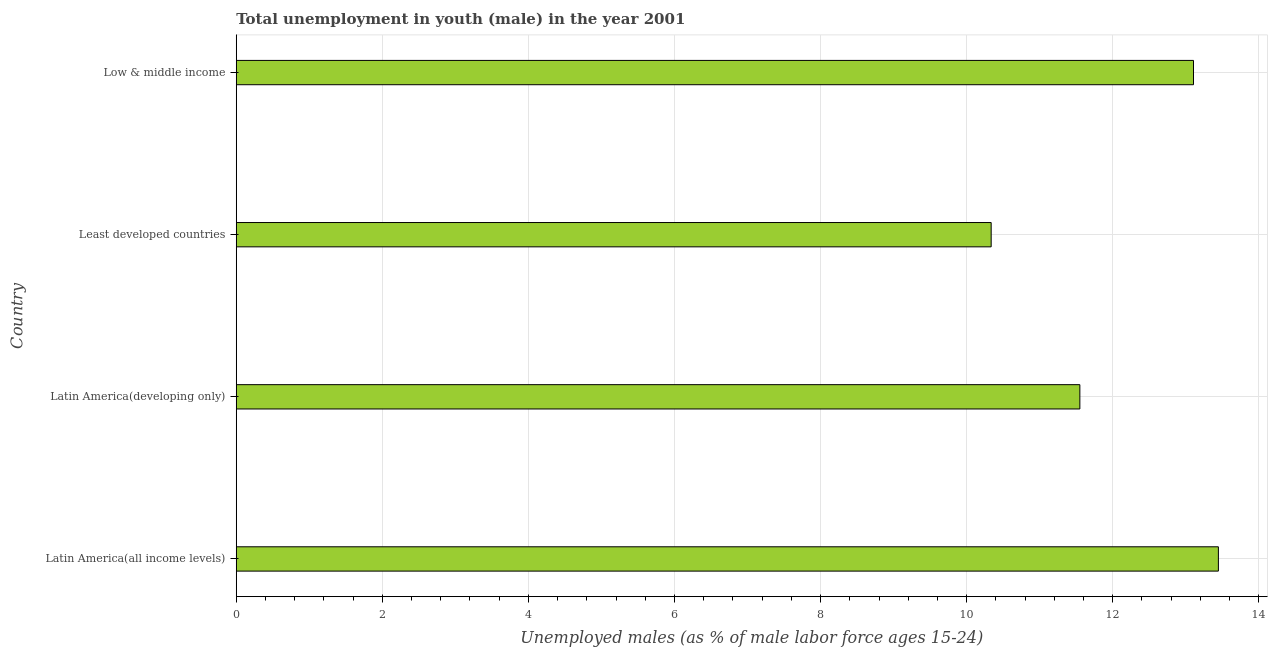Does the graph contain grids?
Your response must be concise. Yes. What is the title of the graph?
Your answer should be very brief. Total unemployment in youth (male) in the year 2001. What is the label or title of the X-axis?
Provide a succinct answer. Unemployed males (as % of male labor force ages 15-24). What is the unemployed male youth population in Low & middle income?
Make the answer very short. 13.11. Across all countries, what is the maximum unemployed male youth population?
Keep it short and to the point. 13.45. Across all countries, what is the minimum unemployed male youth population?
Keep it short and to the point. 10.34. In which country was the unemployed male youth population maximum?
Your answer should be very brief. Latin America(all income levels). In which country was the unemployed male youth population minimum?
Provide a short and direct response. Least developed countries. What is the sum of the unemployed male youth population?
Give a very brief answer. 48.44. What is the difference between the unemployed male youth population in Least developed countries and Low & middle income?
Make the answer very short. -2.77. What is the average unemployed male youth population per country?
Provide a short and direct response. 12.11. What is the median unemployed male youth population?
Provide a succinct answer. 12.33. In how many countries, is the unemployed male youth population greater than 12.8 %?
Your answer should be very brief. 2. What is the ratio of the unemployed male youth population in Latin America(all income levels) to that in Latin America(developing only)?
Provide a succinct answer. 1.16. What is the difference between the highest and the second highest unemployed male youth population?
Offer a terse response. 0.34. Is the sum of the unemployed male youth population in Latin America(all income levels) and Low & middle income greater than the maximum unemployed male youth population across all countries?
Ensure brevity in your answer.  Yes. What is the difference between the highest and the lowest unemployed male youth population?
Your answer should be very brief. 3.11. In how many countries, is the unemployed male youth population greater than the average unemployed male youth population taken over all countries?
Provide a short and direct response. 2. How many countries are there in the graph?
Ensure brevity in your answer.  4. What is the difference between two consecutive major ticks on the X-axis?
Offer a terse response. 2. What is the Unemployed males (as % of male labor force ages 15-24) of Latin America(all income levels)?
Keep it short and to the point. 13.45. What is the Unemployed males (as % of male labor force ages 15-24) in Latin America(developing only)?
Make the answer very short. 11.55. What is the Unemployed males (as % of male labor force ages 15-24) in Least developed countries?
Offer a terse response. 10.34. What is the Unemployed males (as % of male labor force ages 15-24) in Low & middle income?
Provide a succinct answer. 13.11. What is the difference between the Unemployed males (as % of male labor force ages 15-24) in Latin America(all income levels) and Latin America(developing only)?
Ensure brevity in your answer.  1.9. What is the difference between the Unemployed males (as % of male labor force ages 15-24) in Latin America(all income levels) and Least developed countries?
Give a very brief answer. 3.11. What is the difference between the Unemployed males (as % of male labor force ages 15-24) in Latin America(all income levels) and Low & middle income?
Make the answer very short. 0.34. What is the difference between the Unemployed males (as % of male labor force ages 15-24) in Latin America(developing only) and Least developed countries?
Give a very brief answer. 1.21. What is the difference between the Unemployed males (as % of male labor force ages 15-24) in Latin America(developing only) and Low & middle income?
Make the answer very short. -1.56. What is the difference between the Unemployed males (as % of male labor force ages 15-24) in Least developed countries and Low & middle income?
Your answer should be compact. -2.77. What is the ratio of the Unemployed males (as % of male labor force ages 15-24) in Latin America(all income levels) to that in Latin America(developing only)?
Keep it short and to the point. 1.16. What is the ratio of the Unemployed males (as % of male labor force ages 15-24) in Latin America(all income levels) to that in Least developed countries?
Your answer should be compact. 1.3. What is the ratio of the Unemployed males (as % of male labor force ages 15-24) in Latin America(all income levels) to that in Low & middle income?
Offer a terse response. 1.03. What is the ratio of the Unemployed males (as % of male labor force ages 15-24) in Latin America(developing only) to that in Least developed countries?
Keep it short and to the point. 1.12. What is the ratio of the Unemployed males (as % of male labor force ages 15-24) in Latin America(developing only) to that in Low & middle income?
Your response must be concise. 0.88. What is the ratio of the Unemployed males (as % of male labor force ages 15-24) in Least developed countries to that in Low & middle income?
Provide a short and direct response. 0.79. 